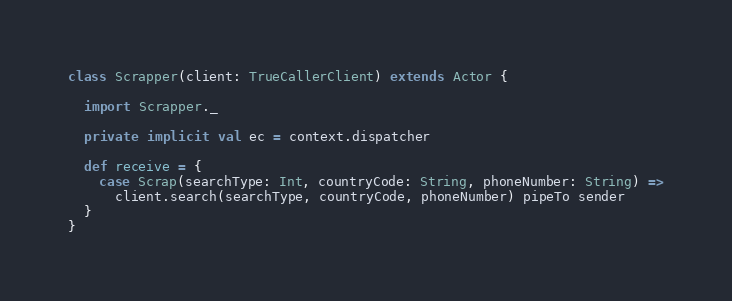Convert code to text. <code><loc_0><loc_0><loc_500><loc_500><_Scala_>
class Scrapper(client: TrueCallerClient) extends Actor {

  import Scrapper._

  private implicit val ec = context.dispatcher

  def receive = {
    case Scrap(searchType: Int, countryCode: String, phoneNumber: String) =>
      client.search(searchType, countryCode, phoneNumber) pipeTo sender
  }
}</code> 